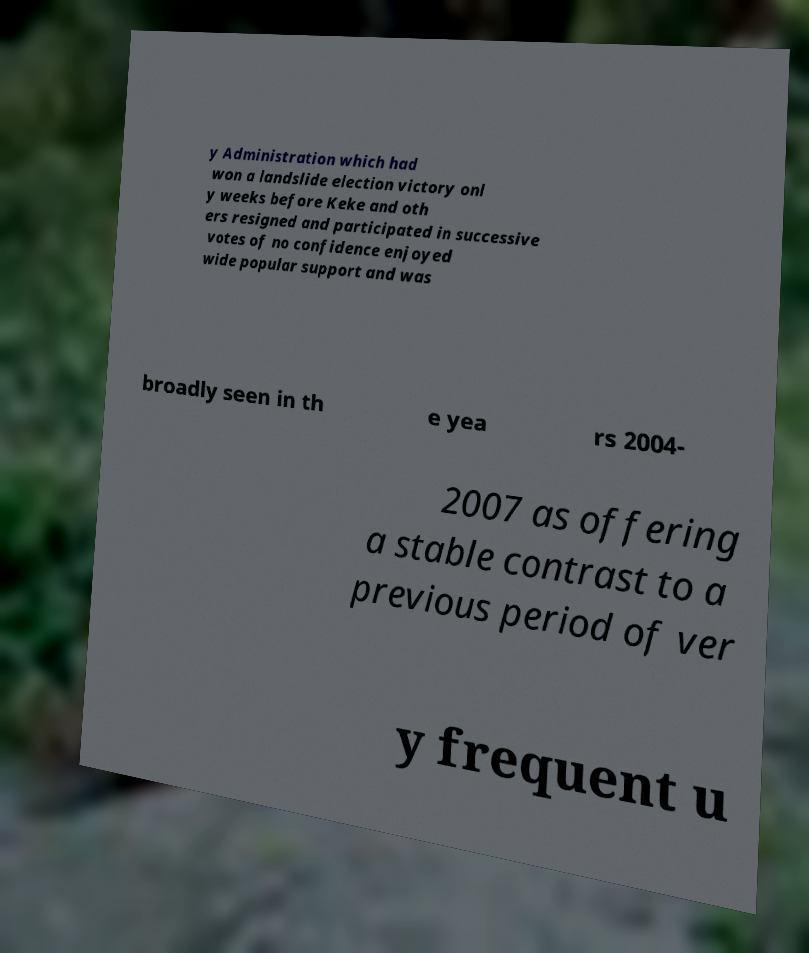Could you extract and type out the text from this image? y Administration which had won a landslide election victory onl y weeks before Keke and oth ers resigned and participated in successive votes of no confidence enjoyed wide popular support and was broadly seen in th e yea rs 2004- 2007 as offering a stable contrast to a previous period of ver y frequent u 